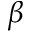Convert formula to latex. <formula><loc_0><loc_0><loc_500><loc_500>\beta</formula> 